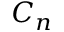Convert formula to latex. <formula><loc_0><loc_0><loc_500><loc_500>C _ { n }</formula> 